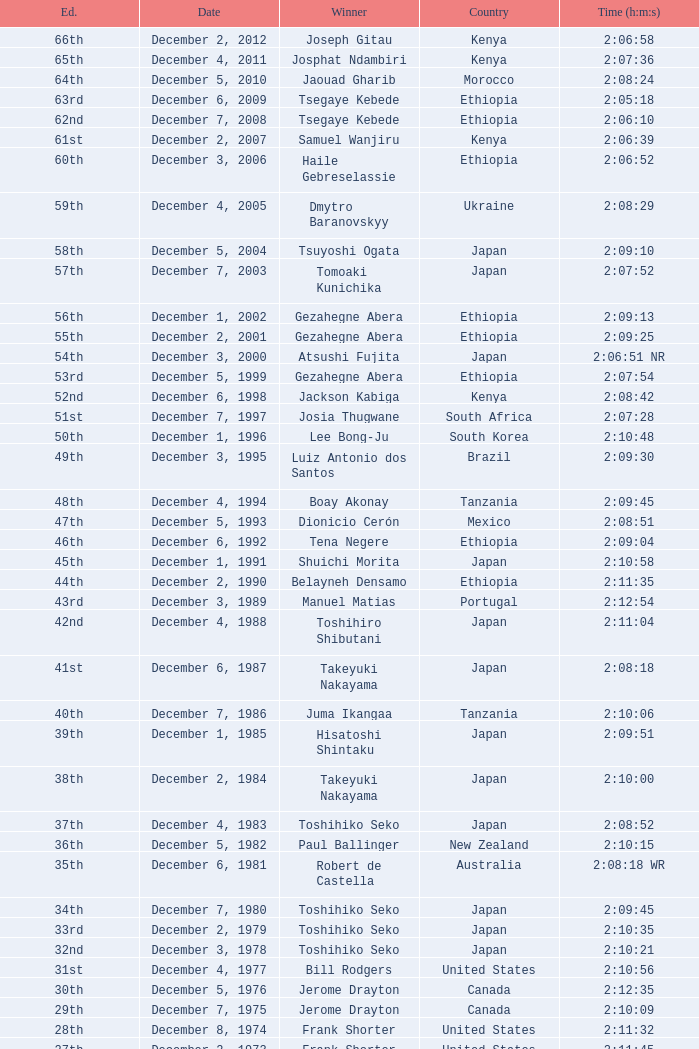On what date did Lee Bong-Ju win in 2:10:48? December 1, 1996. 